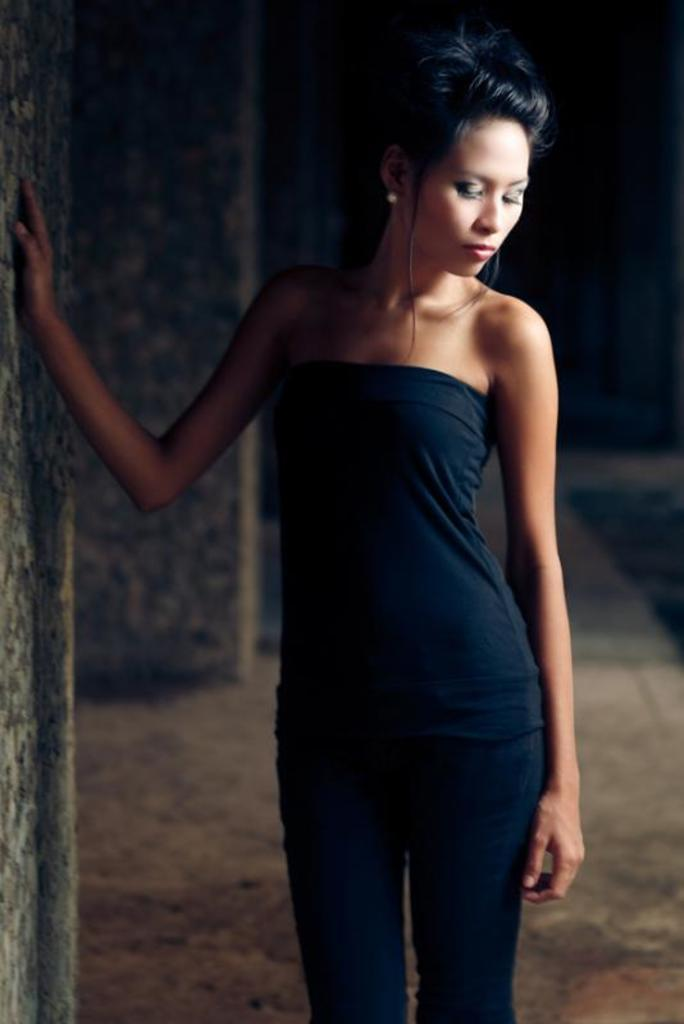Who is present in the image? There is a woman in the image. What is the woman's position in the image? The woman is standing on the ground. What can be seen to the left of the woman in the image? There are pillars to the left in the image. How would you describe the overall lighting in the image? The background of the image is dark. What type of flesh can be seen hanging from the pillars in the image? There is no flesh present in the image; it only features a woman standing near pillars with a dark background. 